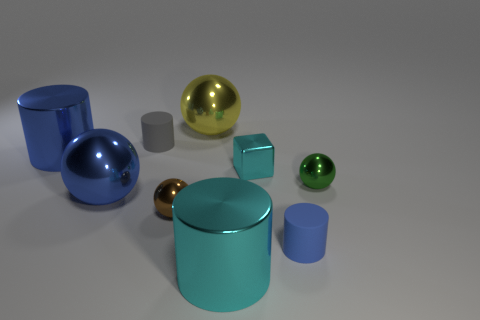Subtract all brown balls. How many balls are left? 3 Subtract all blue metal cylinders. How many cylinders are left? 3 Subtract 1 cylinders. How many cylinders are left? 3 Add 1 large purple shiny cubes. How many objects exist? 10 Subtract all gray balls. Subtract all green blocks. How many balls are left? 4 Subtract all spheres. How many objects are left? 5 Subtract all small yellow things. Subtract all blue shiny objects. How many objects are left? 7 Add 1 small gray matte cylinders. How many small gray matte cylinders are left? 2 Add 1 purple cylinders. How many purple cylinders exist? 1 Subtract 1 brown spheres. How many objects are left? 8 